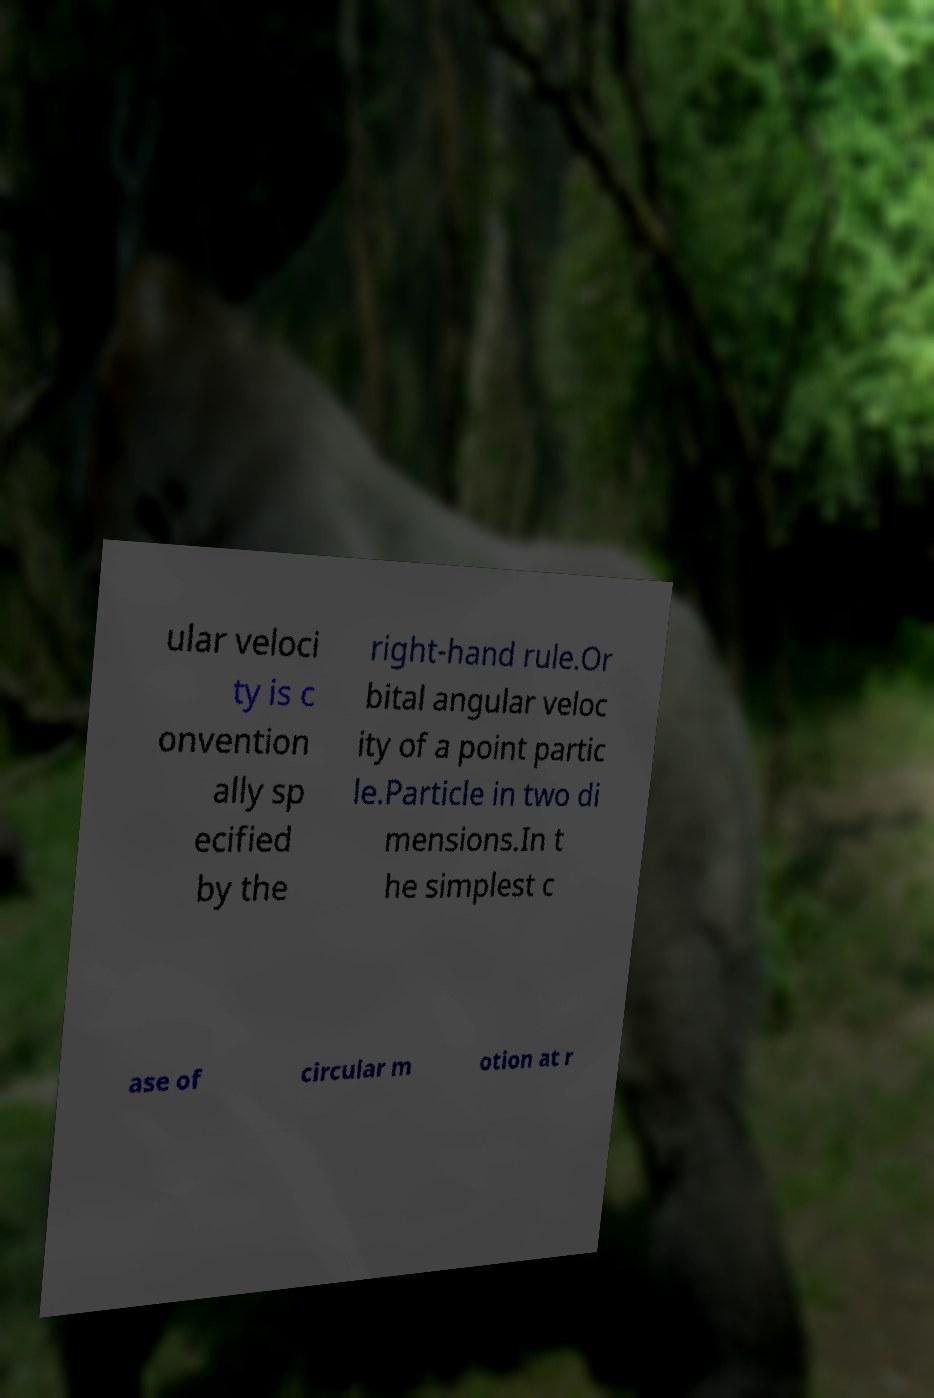Could you extract and type out the text from this image? ular veloci ty is c onvention ally sp ecified by the right-hand rule.Or bital angular veloc ity of a point partic le.Particle in two di mensions.In t he simplest c ase of circular m otion at r 